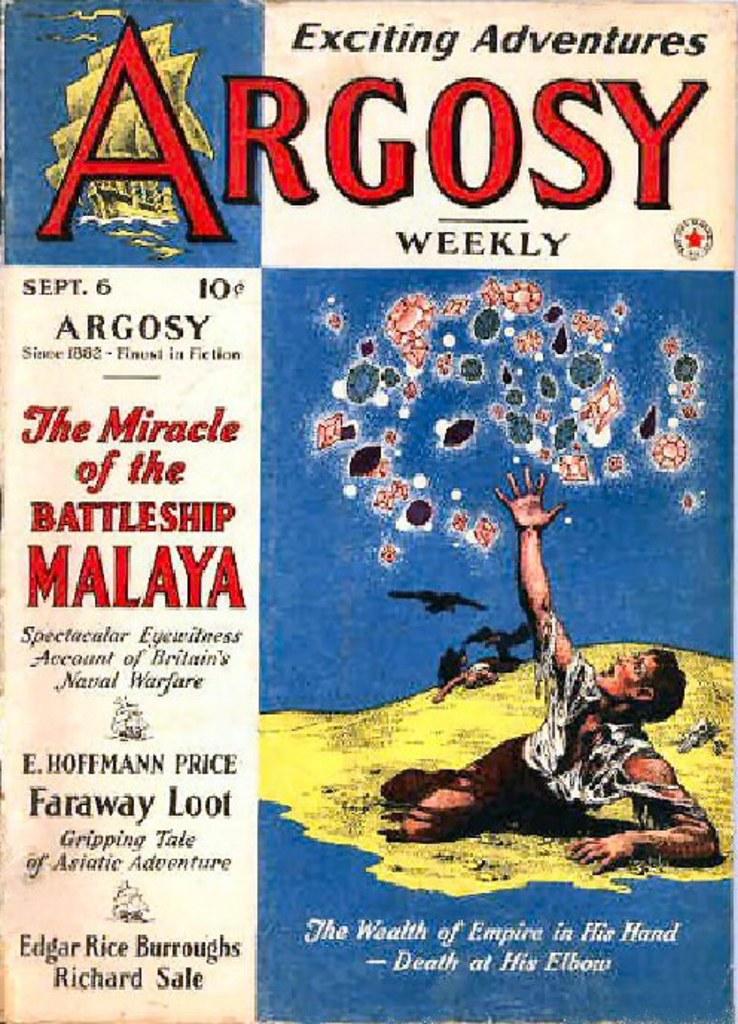What weekly publication is this?
Your answer should be very brief. Argosy. What is the title of the ad?
Ensure brevity in your answer.  Argosy. 